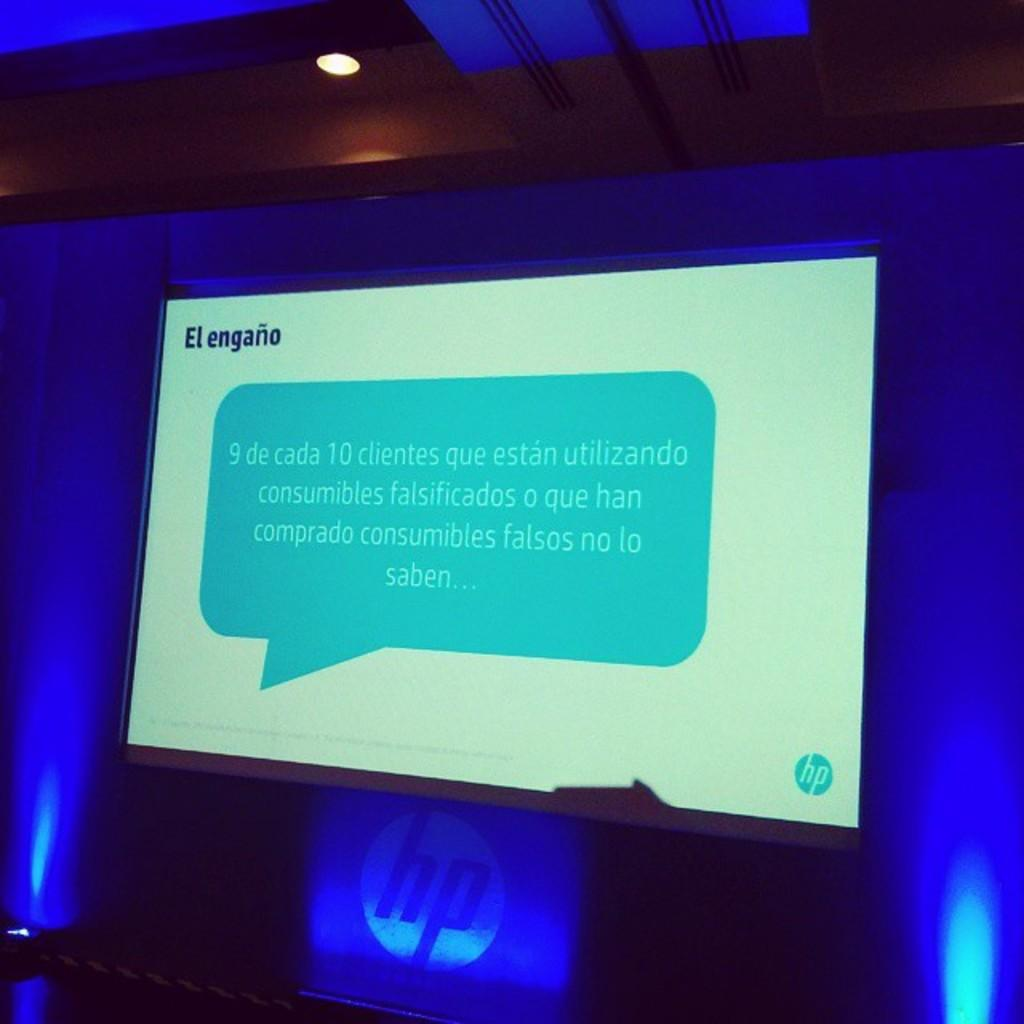<image>
Give a short and clear explanation of the subsequent image. A monitor screen in a blue light room with a presentation in spanish 